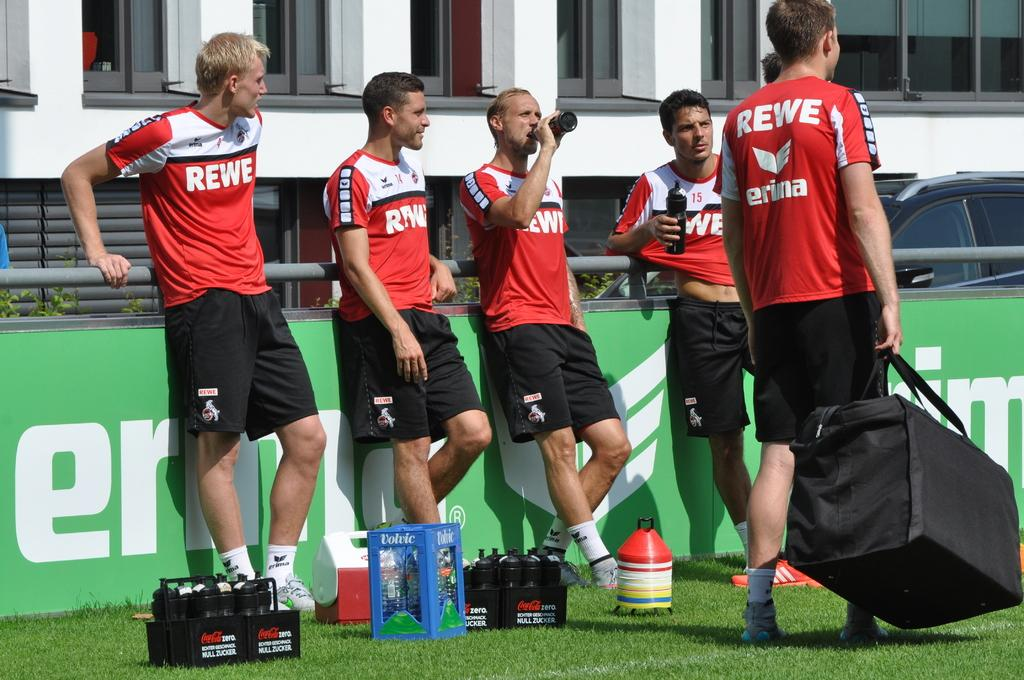<image>
Describe the image concisely. Several soccer players wear red jerseys with Rewe written on them. 